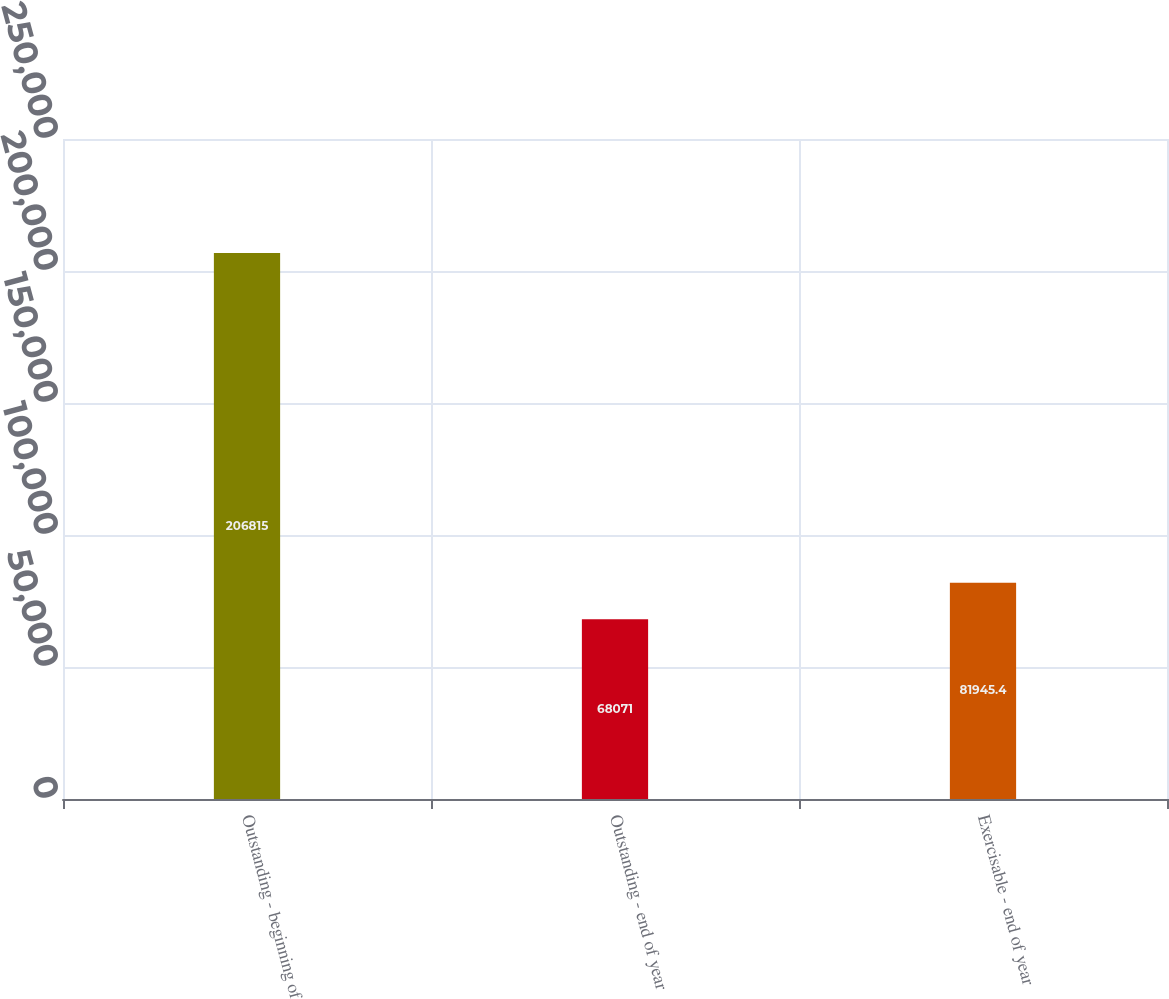Convert chart. <chart><loc_0><loc_0><loc_500><loc_500><bar_chart><fcel>Outstanding - beginning of<fcel>Outstanding - end of year<fcel>Exercisable - end of year<nl><fcel>206815<fcel>68071<fcel>81945.4<nl></chart> 